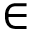Convert formula to latex. <formula><loc_0><loc_0><loc_500><loc_500>\in</formula> 